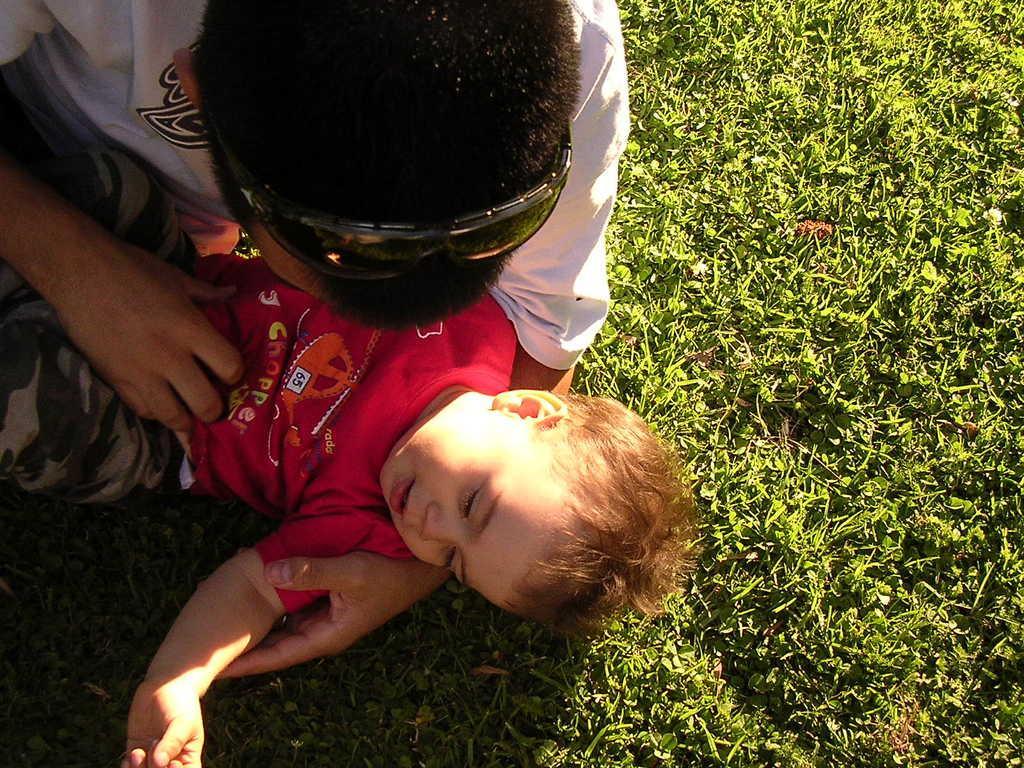Can you describe this image briefly? In this picture we can see goggles and two people on the grass. 